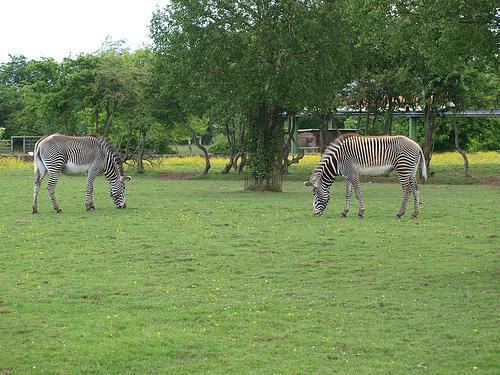How many zebras are there?
Give a very brief answer. 2. 